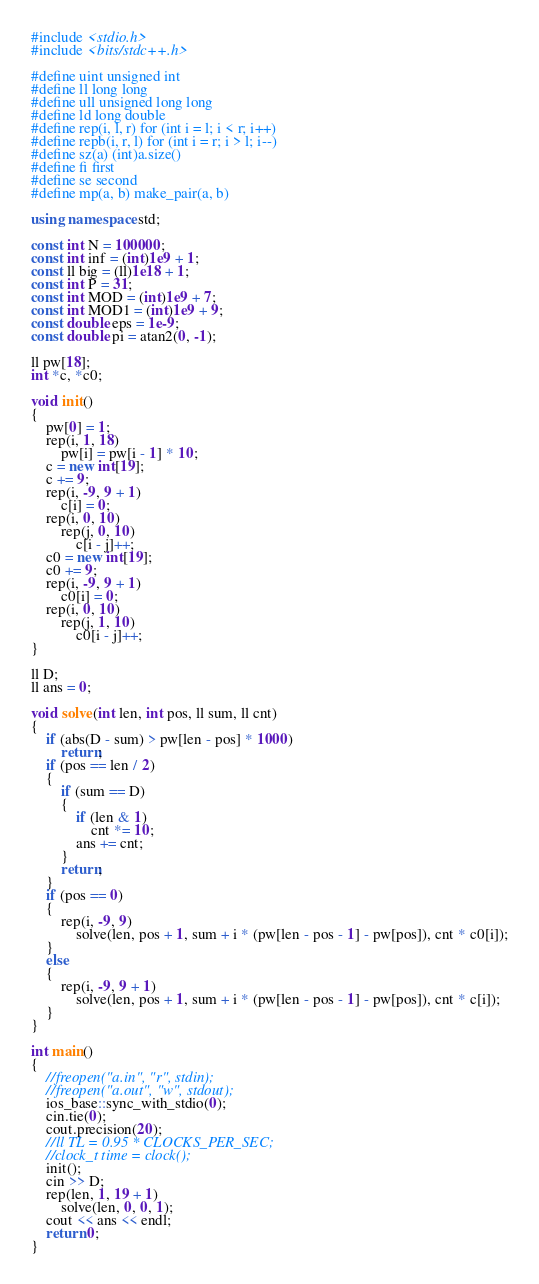<code> <loc_0><loc_0><loc_500><loc_500><_C++_>#include <stdio.h>
#include <bits/stdc++.h>
 
#define uint unsigned int
#define ll long long
#define ull unsigned long long
#define ld long double
#define rep(i, l, r) for (int i = l; i < r; i++)
#define repb(i, r, l) for (int i = r; i > l; i--)
#define sz(a) (int)a.size()
#define fi first
#define se second
#define mp(a, b) make_pair(a, b)
 
using namespace std;
 
const int N = 100000;
const int inf = (int)1e9 + 1;
const ll big = (ll)1e18 + 1;
const int P = 31;
const int MOD = (int)1e9 + 7;
const int MOD1 = (int)1e9 + 9;
const double eps = 1e-9;
const double pi = atan2(0, -1);
 
ll pw[18];
int *c, *c0;
 
void init()
{
    pw[0] = 1;
    rep(i, 1, 18)
        pw[i] = pw[i - 1] * 10;
    c = new int[19];
    c += 9;
    rep(i, -9, 9 + 1)
        c[i] = 0;
    rep(i, 0, 10)
        rep(j, 0, 10)
            c[i - j]++;
    c0 = new int[19];
    c0 += 9;
    rep(i, -9, 9 + 1)
        c0[i] = 0;
    rep(i, 0, 10)
        rep(j, 1, 10)
            c0[i - j]++;
}
 
ll D;
ll ans = 0;
 
void solve(int len, int pos, ll sum, ll cnt)
{
    if (abs(D - sum) > pw[len - pos] * 1000)
        return;
    if (pos == len / 2)
    {
        if (sum == D)
        {
            if (len & 1)
                cnt *= 10;
            ans += cnt;
        }
        return;
    }
    if (pos == 0)
    {
        rep(i, -9, 9)
            solve(len, pos + 1, sum + i * (pw[len - pos - 1] - pw[pos]), cnt * c0[i]);
    }
    else
    {
        rep(i, -9, 9 + 1)
            solve(len, pos + 1, sum + i * (pw[len - pos - 1] - pw[pos]), cnt * c[i]);
    }
}
 
int main()
{
    //freopen("a.in", "r", stdin);
    //freopen("a.out", "w", stdout);
    ios_base::sync_with_stdio(0);
    cin.tie(0);
    cout.precision(20);
    //ll TL = 0.95 * CLOCKS_PER_SEC;
    //clock_t time = clock();
    init();
    cin >> D;
    rep(len, 1, 19 + 1)
        solve(len, 0, 0, 1);
    cout << ans << endl;
    return 0;
}</code> 